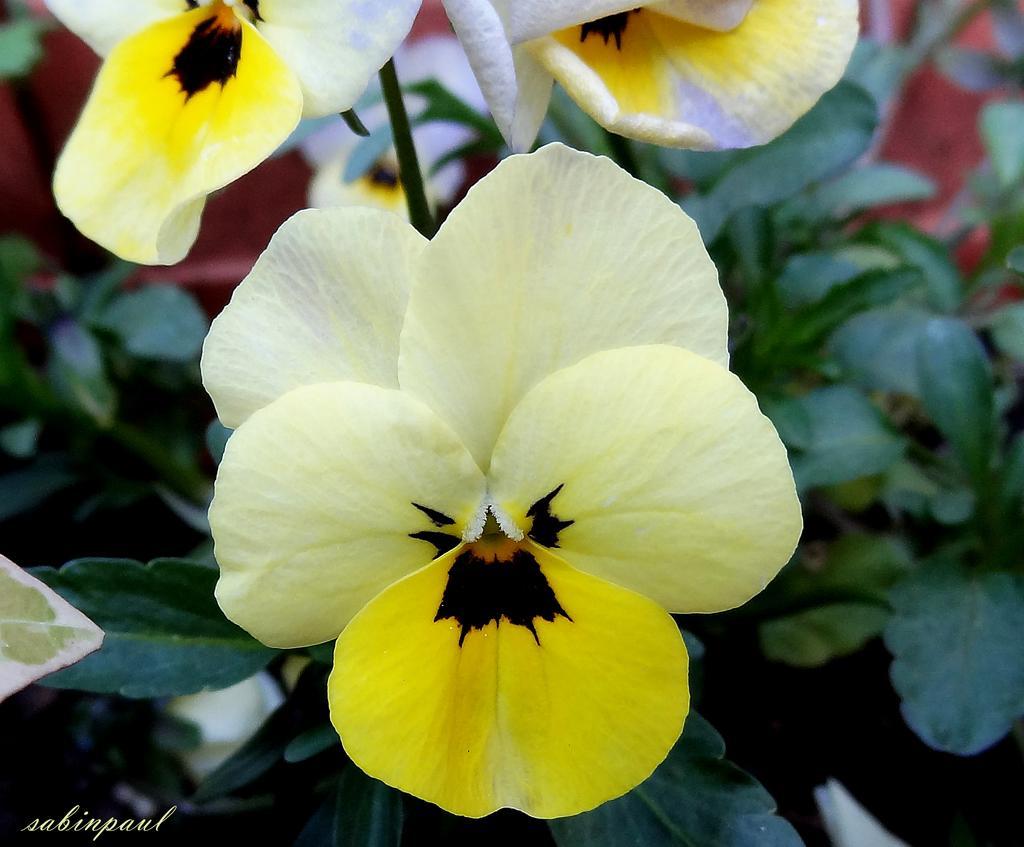Can you describe this image briefly? In the picture we can see some plants and flowers to it which are yellow in color. 